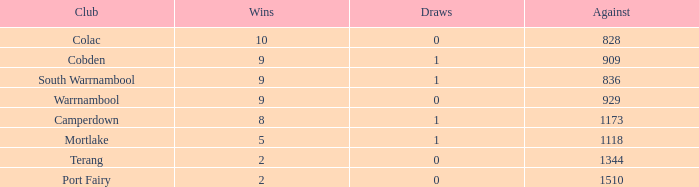How many wins does port fairy have when the opposition scores under 1510 points? None. 